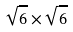Convert formula to latex. <formula><loc_0><loc_0><loc_500><loc_500>\sqrt { 6 } \times \sqrt { 6 }</formula> 